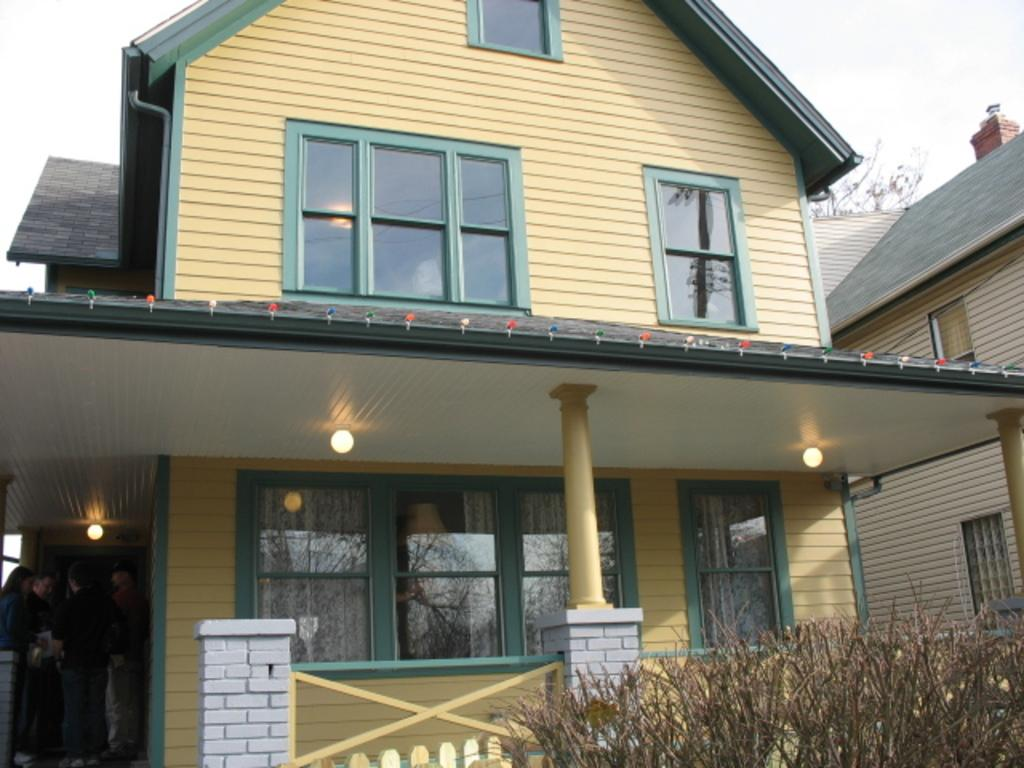What type of structures can be seen in the image? There are houses with windows in the image. What other elements are present in the image besides the houses? There are plants, lights, a fence, a group of people, a tree, and the sky visible in the background. Can you describe the group of people in the image? There is a group of people standing in the image. What type of plot is being attacked by a train in the image? There is no plot or train present in the image; it features houses, plants, lights, a fence, a group of people, a tree, and the sky. 